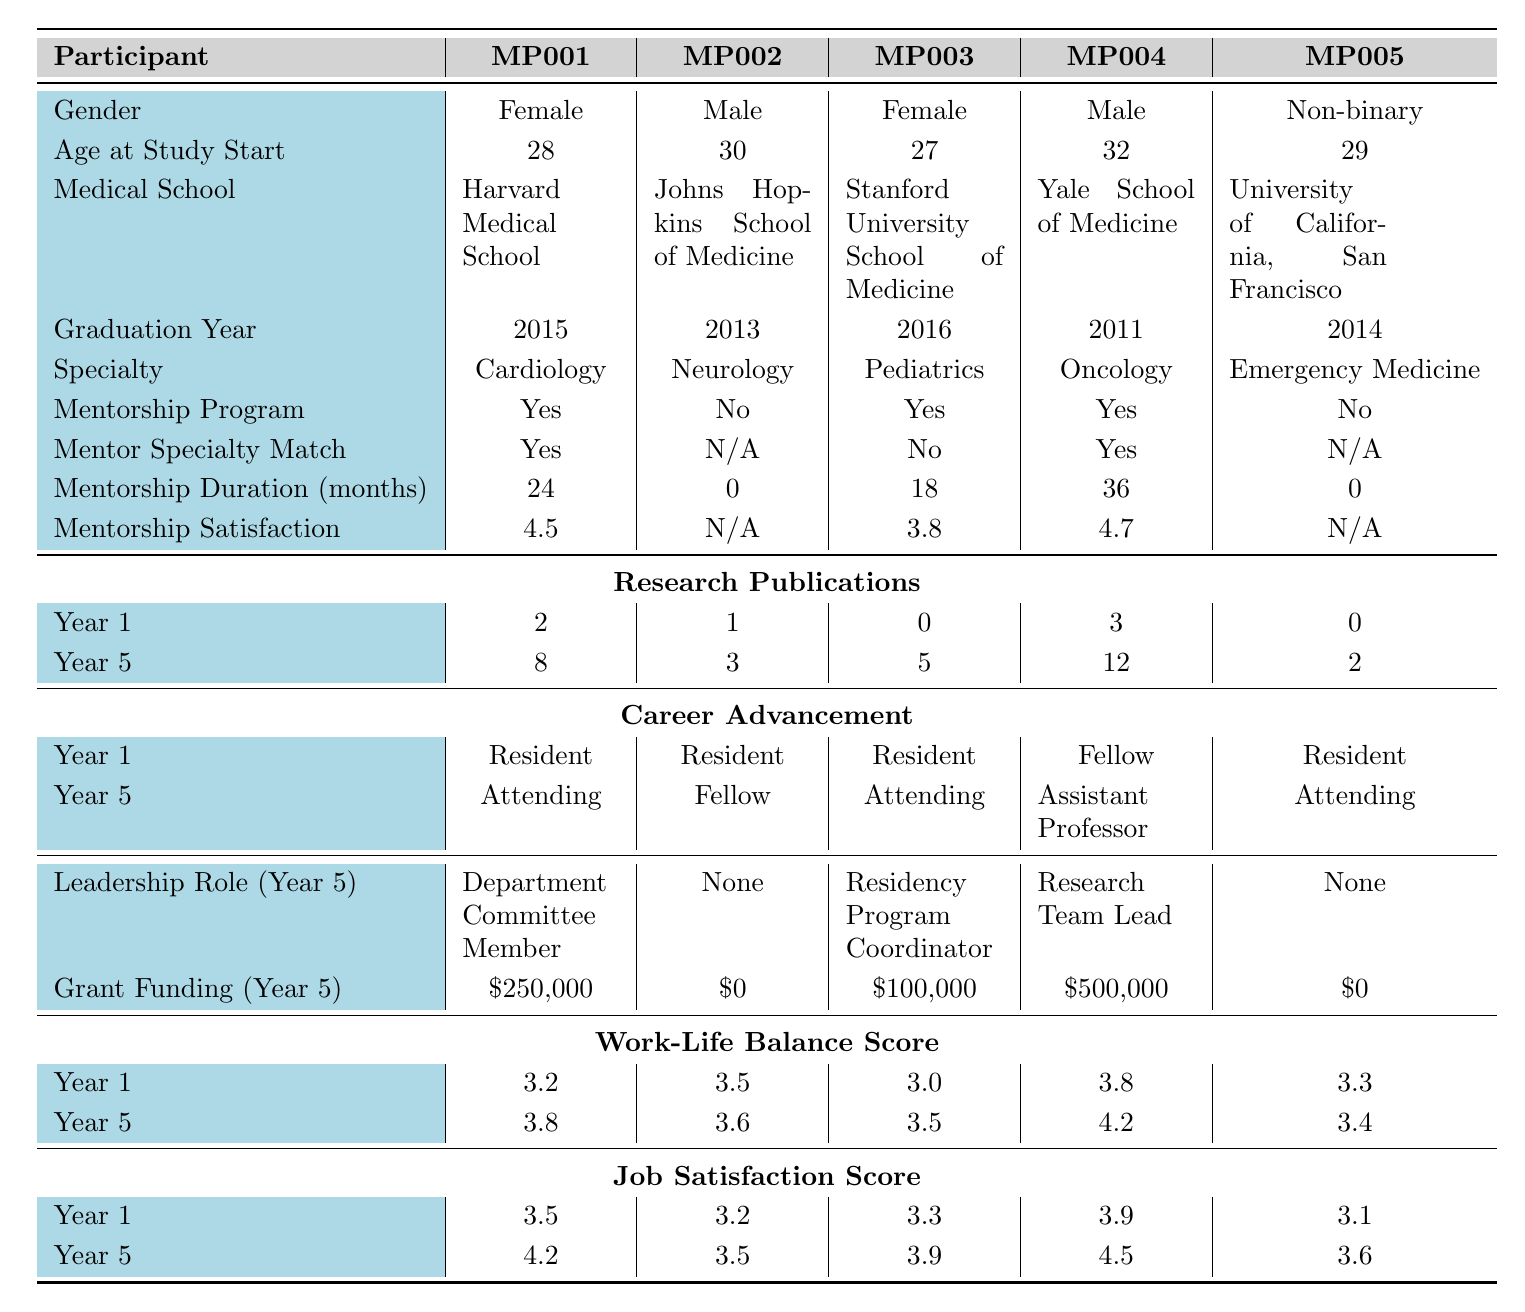What is the mentorship satisfaction score of participant MP001? The mentorship satisfaction score for participant MP001 is directly listed in the table as 4.5.
Answer: 4.5 How many research publications did participant MP004 have in year 1? In year 1, participant MP004's research publications are recorded as 3 in the table.
Answer: 3 Did participant MP002 participate in a mentorship program? The table indicates that participant MP002 did not participate in a mentorship program as it is marked "No."
Answer: No What is the average work-life balance score for all participants in year 5? By summing the work-life balance scores for year 5 (3.8 + 3.6 + 3.5 + 4.2 + 3.4 + 3.7 + 3.6 + 4.0 + 3.8 + 3.9 = 37.5) and dividing by the number of participants (10), the average is 37.5 / 10 = 3.75.
Answer: 3.75 Which participant has the highest grant funding secured in year 5? According to the table, participant MP004 secured the highest grant funding with an amount of $500,000.
Answer: MP004 How many participants reported a job satisfaction score of 4.0 or higher in year 5? Participants with scores of 4.0 or higher in year 5 include MP001, MP004, MP006, MP008, and MP010, totaling 5 participants.
Answer: 5 What was the career advancement of participant MP003 after five years? The table shows that participant MP003 advanced to "Attending" after five years, from "Resident."
Answer: Attending What is the difference between the research publications of participant MP005 from year 1 to year 5? For participant MP005, the publications were 0 in year 1 and increased to 2 in year 5, resulting in a difference of 2 - 0 = 2 publications.
Answer: 2 How many participants had a mentor specialty match and also participated in a mentorship program? The mentor specialty match and mentorship program participation are both confirmed for participants MP001, MP004, MP006, and MP010, leading to a total of 4 participants.
Answer: 4 What trend can you observe in job satisfaction scores between year 1 and year 5 for participant MP006? Participant MP006's job satisfaction score increased from 3.6 in year 1 to 4.3 in year 5, indicating an upward trend in job satisfaction over that period.
Answer: Increase 